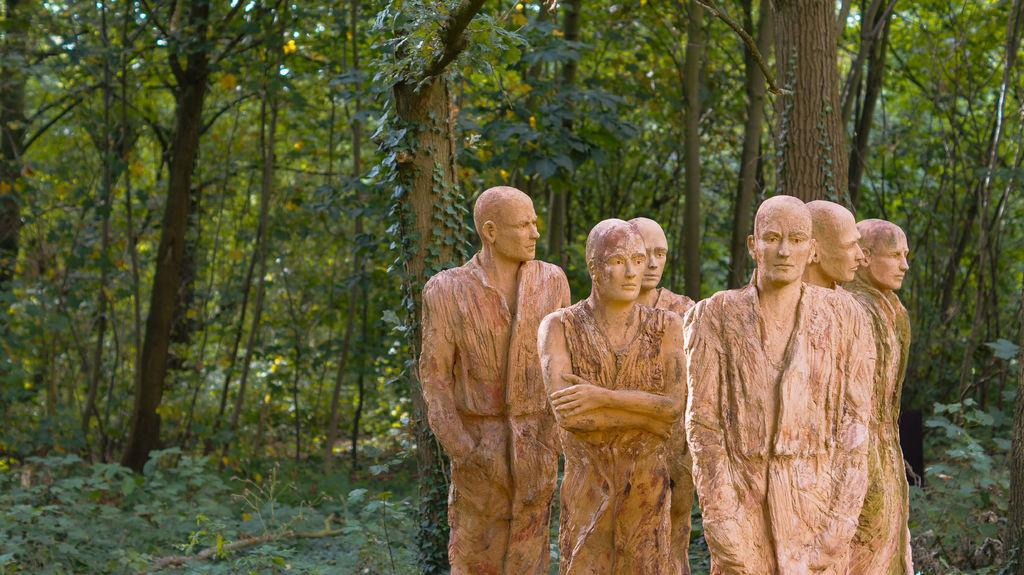What is the main subject of the image? There is a depiction of a person in the center of the image. What can be seen in the background of the image? There are trees in the background of the image. What type of screw can be seen holding the wing in place in the image? There is no screw or wing present in the image; it features a depiction of a person and trees in the background. 